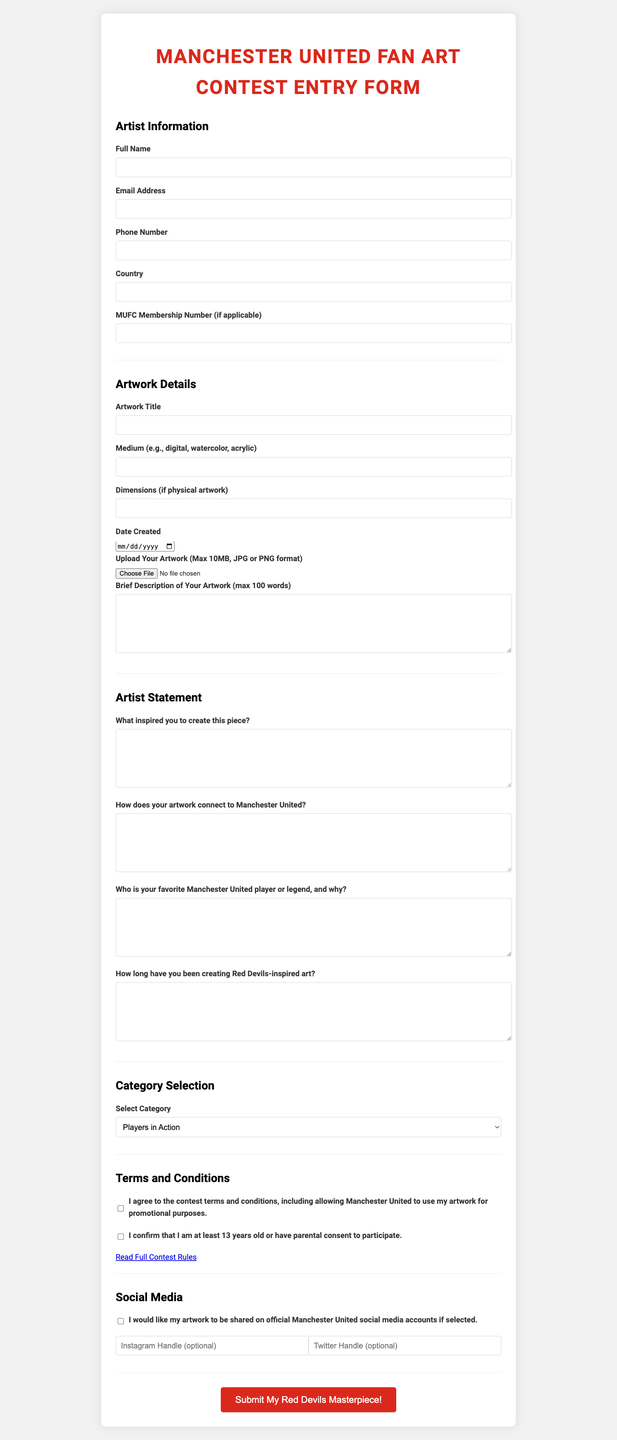What is the title of the form? The form is titled "Manchester United Fan Art Contest Entry Form."
Answer: Manchester United Fan Art Contest Entry Form What is the maximum file size for artwork uploads? The form specifies a maximum file size of 10MB for artwork uploads.
Answer: 10MB Who should confirm their age in the terms and conditions? Participants should confirm that they are at least 13 years old or have parental consent to participate.
Answer: Participants aged 13 and above What artwork category options are available? The available category options include "Players in Action," "Old Trafford Scenes," and others listed in the document.
Answer: Players in Action, Old Trafford Scenes, Club Legends, Fan Culture, Club History, Future of MUFC What is required in the brief description of the artwork? The brief description must be a maximum of 100 words.
Answer: Max 100 words What type of social media handles can be provided? The form allows for optional Instagram and Twitter handles to be provided.
Answer: Instagram and Twitter handles What is the main purpose of the contest? The main purpose of the contest is to encourage participants to share their fan artwork related to Manchester United.
Answer: Fan artwork related to Manchester United What must the artist include in their statement regarding inspiration? Artists must describe what inspired them to create their piece of artwork.
Answer: Inspiration description What happens if selected artwork is shared on social media? Selected artwork may be shared on official Manchester United social media accounts.
Answer: Shared on social media accounts 